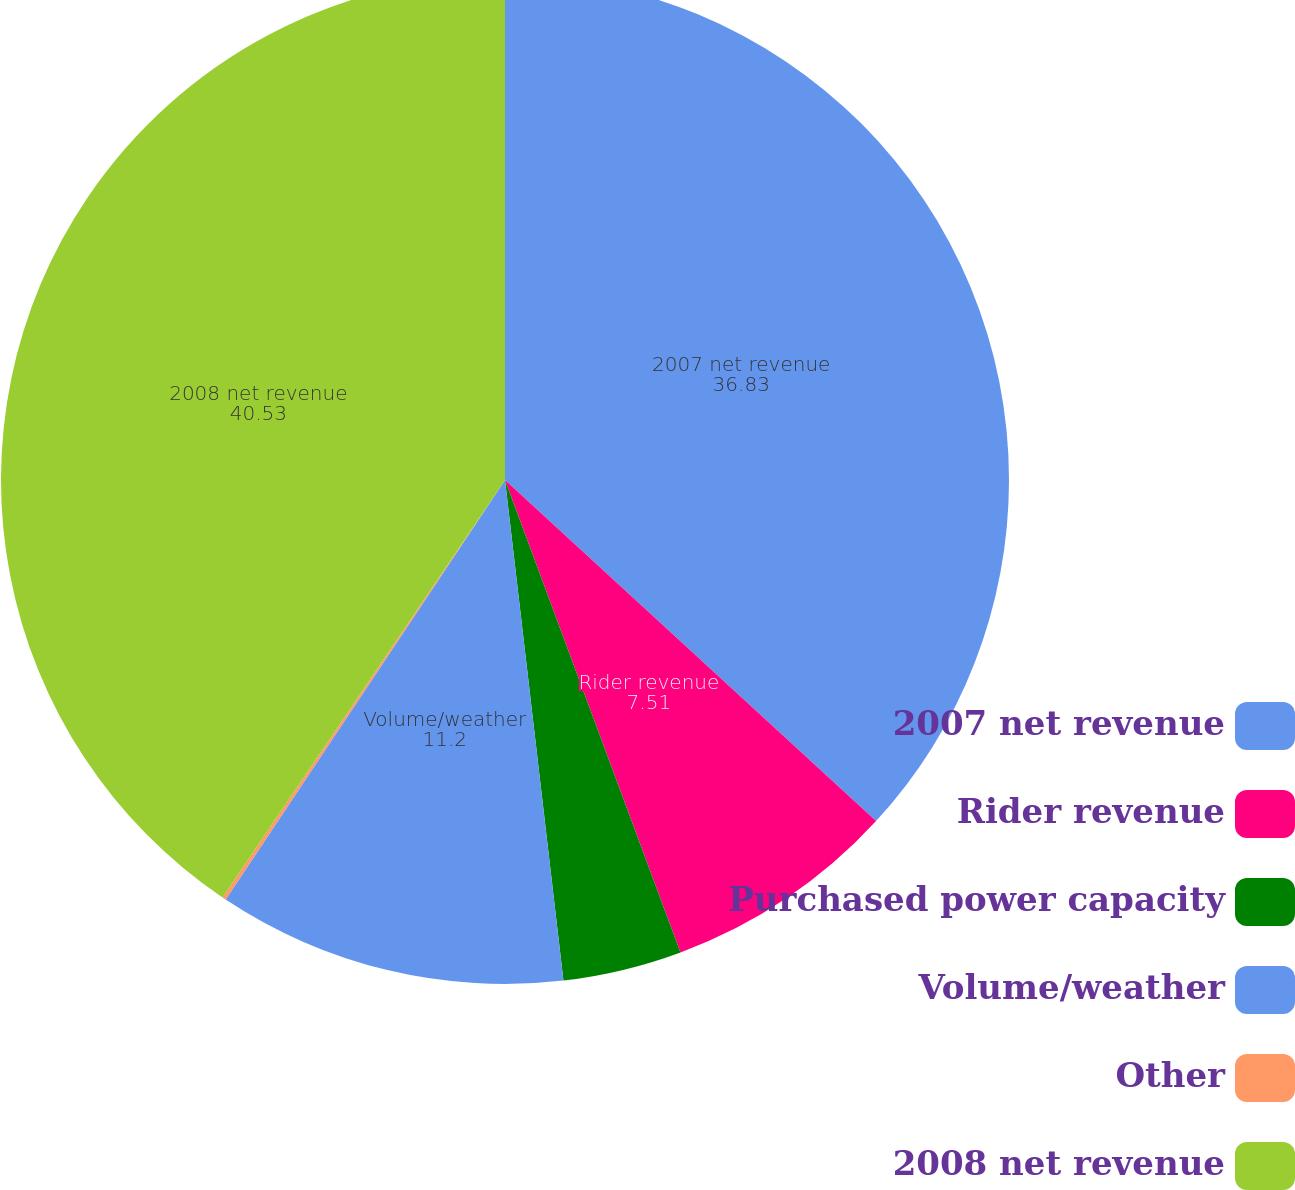Convert chart to OTSL. <chart><loc_0><loc_0><loc_500><loc_500><pie_chart><fcel>2007 net revenue<fcel>Rider revenue<fcel>Purchased power capacity<fcel>Volume/weather<fcel>Other<fcel>2008 net revenue<nl><fcel>36.83%<fcel>7.51%<fcel>3.81%<fcel>11.2%<fcel>0.12%<fcel>40.53%<nl></chart> 